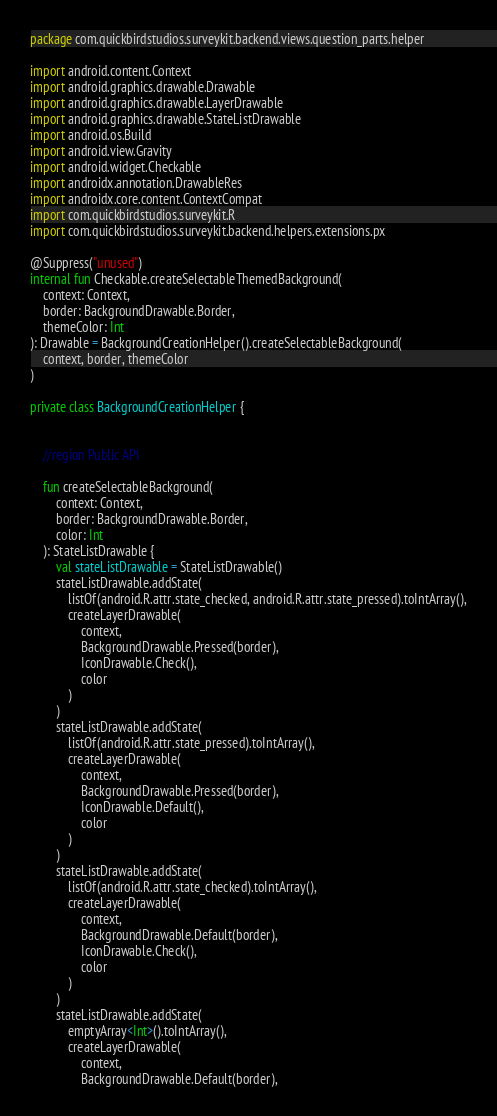<code> <loc_0><loc_0><loc_500><loc_500><_Kotlin_>package com.quickbirdstudios.surveykit.backend.views.question_parts.helper

import android.content.Context
import android.graphics.drawable.Drawable
import android.graphics.drawable.LayerDrawable
import android.graphics.drawable.StateListDrawable
import android.os.Build
import android.view.Gravity
import android.widget.Checkable
import androidx.annotation.DrawableRes
import androidx.core.content.ContextCompat
import com.quickbirdstudios.surveykit.R
import com.quickbirdstudios.surveykit.backend.helpers.extensions.px

@Suppress("unused")
internal fun Checkable.createSelectableThemedBackground(
    context: Context,
    border: BackgroundDrawable.Border,
    themeColor: Int
): Drawable = BackgroundCreationHelper().createSelectableBackground(
    context, border, themeColor
)

private class BackgroundCreationHelper {


    //region Public API

    fun createSelectableBackground(
        context: Context,
        border: BackgroundDrawable.Border,
        color: Int
    ): StateListDrawable {
        val stateListDrawable = StateListDrawable()
        stateListDrawable.addState(
            listOf(android.R.attr.state_checked, android.R.attr.state_pressed).toIntArray(),
            createLayerDrawable(
                context,
                BackgroundDrawable.Pressed(border),
                IconDrawable.Check(),
                color
            )
        )
        stateListDrawable.addState(
            listOf(android.R.attr.state_pressed).toIntArray(),
            createLayerDrawable(
                context,
                BackgroundDrawable.Pressed(border),
                IconDrawable.Default(),
                color
            )
        )
        stateListDrawable.addState(
            listOf(android.R.attr.state_checked).toIntArray(),
            createLayerDrawable(
                context,
                BackgroundDrawable.Default(border),
                IconDrawable.Check(),
                color
            )
        )
        stateListDrawable.addState(
            emptyArray<Int>().toIntArray(),
            createLayerDrawable(
                context,
                BackgroundDrawable.Default(border),</code> 